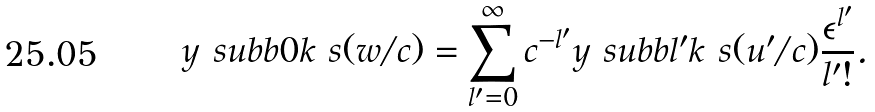<formula> <loc_0><loc_0><loc_500><loc_500>y \ s u b b 0 k \ s ( w / c ) = \sum _ { l ^ { \prime } = 0 } ^ { \infty } c ^ { - l ^ { \prime } } y \ s u b b { l ^ { \prime } } k \ s ( u ^ { \prime } / c ) \frac { \epsilon ^ { l ^ { \prime } } } { l ^ { \prime } ! } .</formula> 